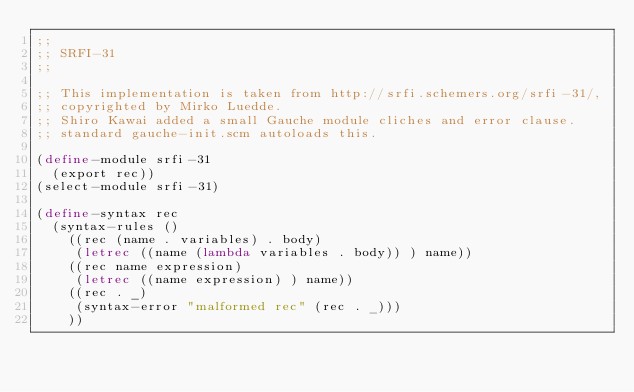Convert code to text. <code><loc_0><loc_0><loc_500><loc_500><_Scheme_>;;
;; SRFI-31
;;

;; This implementation is taken from http://srfi.schemers.org/srfi-31/,
;; copyrighted by Mirko Luedde.
;; Shiro Kawai added a small Gauche module cliches and error clause.
;; standard gauche-init.scm autoloads this.

(define-module srfi-31
  (export rec))
(select-module srfi-31)

(define-syntax rec
  (syntax-rules ()
    ((rec (name . variables) . body)
     (letrec ((name (lambda variables . body)) ) name))
    ((rec name expression)
     (letrec ((name expression) ) name))
    ((rec . _)
     (syntax-error "malformed rec" (rec . _)))
    ))



</code> 